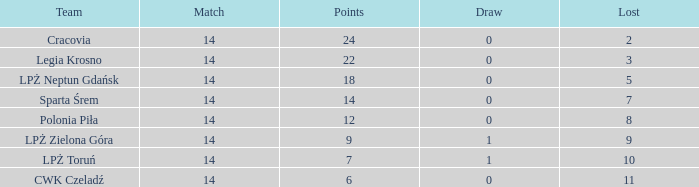What is the total for the game with a tie less than 0? None. 